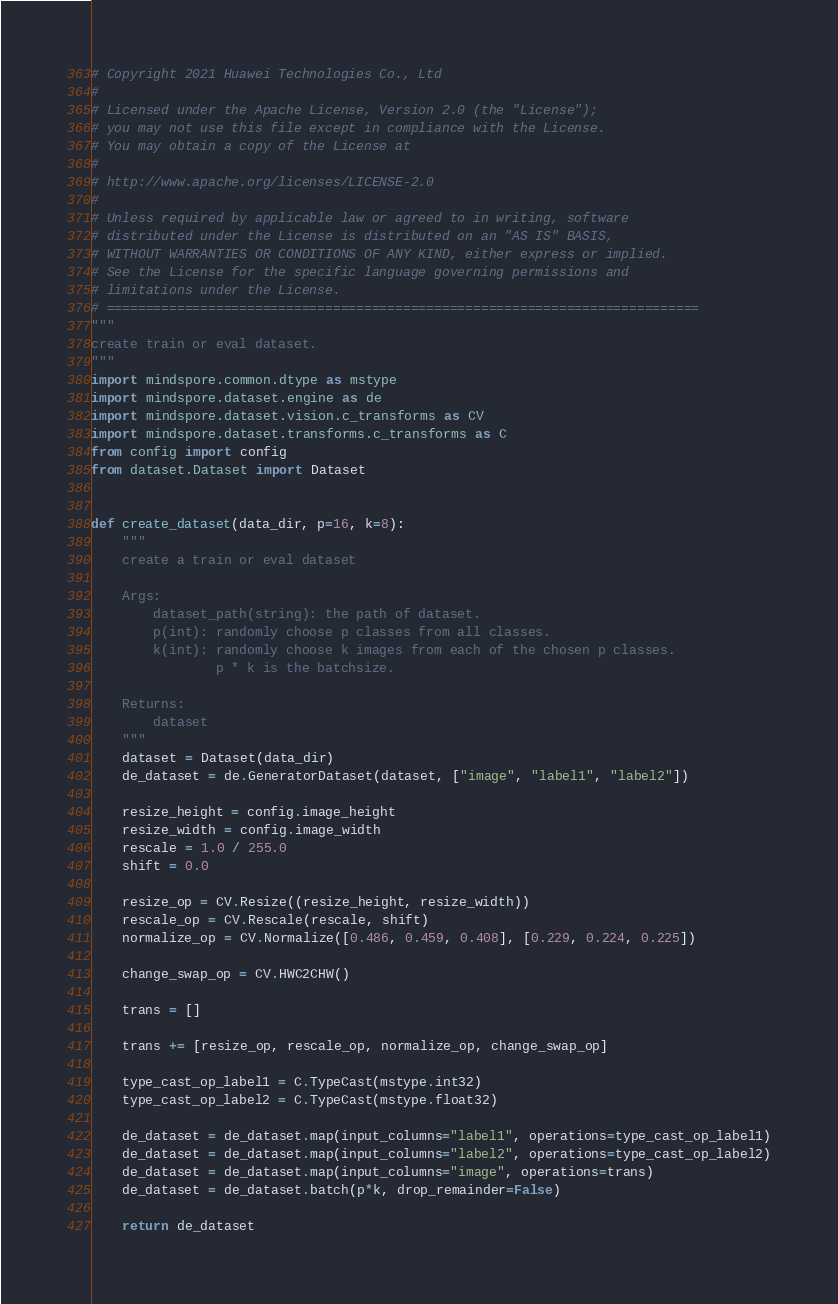Convert code to text. <code><loc_0><loc_0><loc_500><loc_500><_Python_># Copyright 2021 Huawei Technologies Co., Ltd
#
# Licensed under the Apache License, Version 2.0 (the "License");
# you may not use this file except in compliance with the License.
# You may obtain a copy of the License at
#
# http://www.apache.org/licenses/LICENSE-2.0
#
# Unless required by applicable law or agreed to in writing, software
# distributed under the License is distributed on an "AS IS" BASIS,
# WITHOUT WARRANTIES OR CONDITIONS OF ANY KIND, either express or implied.
# See the License for the specific language governing permissions and
# limitations under the License.
# ============================================================================
"""
create train or eval dataset.
"""
import mindspore.common.dtype as mstype
import mindspore.dataset.engine as de
import mindspore.dataset.vision.c_transforms as CV
import mindspore.dataset.transforms.c_transforms as C
from config import config
from dataset.Dataset import Dataset


def create_dataset(data_dir, p=16, k=8):
    """
    create a train or eval dataset

    Args:
        dataset_path(string): the path of dataset.
        p(int): randomly choose p classes from all classes.
        k(int): randomly choose k images from each of the chosen p classes.
                p * k is the batchsize.

    Returns:
        dataset
    """
    dataset = Dataset(data_dir)
    de_dataset = de.GeneratorDataset(dataset, ["image", "label1", "label2"])

    resize_height = config.image_height
    resize_width = config.image_width
    rescale = 1.0 / 255.0
    shift = 0.0

    resize_op = CV.Resize((resize_height, resize_width))
    rescale_op = CV.Rescale(rescale, shift)
    normalize_op = CV.Normalize([0.486, 0.459, 0.408], [0.229, 0.224, 0.225])

    change_swap_op = CV.HWC2CHW()

    trans = []

    trans += [resize_op, rescale_op, normalize_op, change_swap_op]

    type_cast_op_label1 = C.TypeCast(mstype.int32)
    type_cast_op_label2 = C.TypeCast(mstype.float32)

    de_dataset = de_dataset.map(input_columns="label1", operations=type_cast_op_label1)
    de_dataset = de_dataset.map(input_columns="label2", operations=type_cast_op_label2)
    de_dataset = de_dataset.map(input_columns="image", operations=trans)
    de_dataset = de_dataset.batch(p*k, drop_remainder=False)

    return de_dataset
</code> 